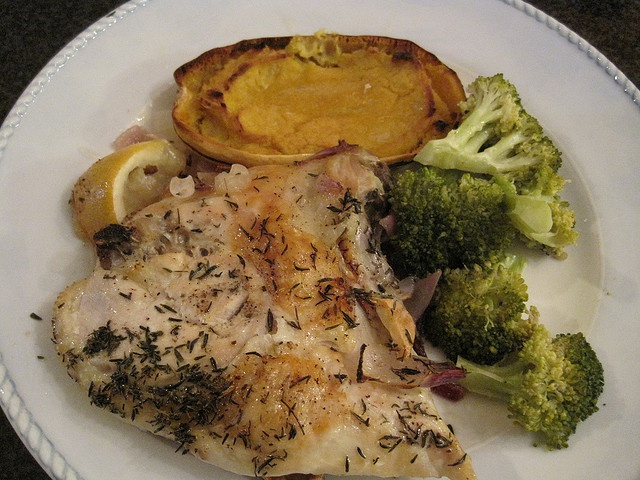Describe the objects in this image and their specific colors. I can see a broccoli in black and olive tones in this image. 